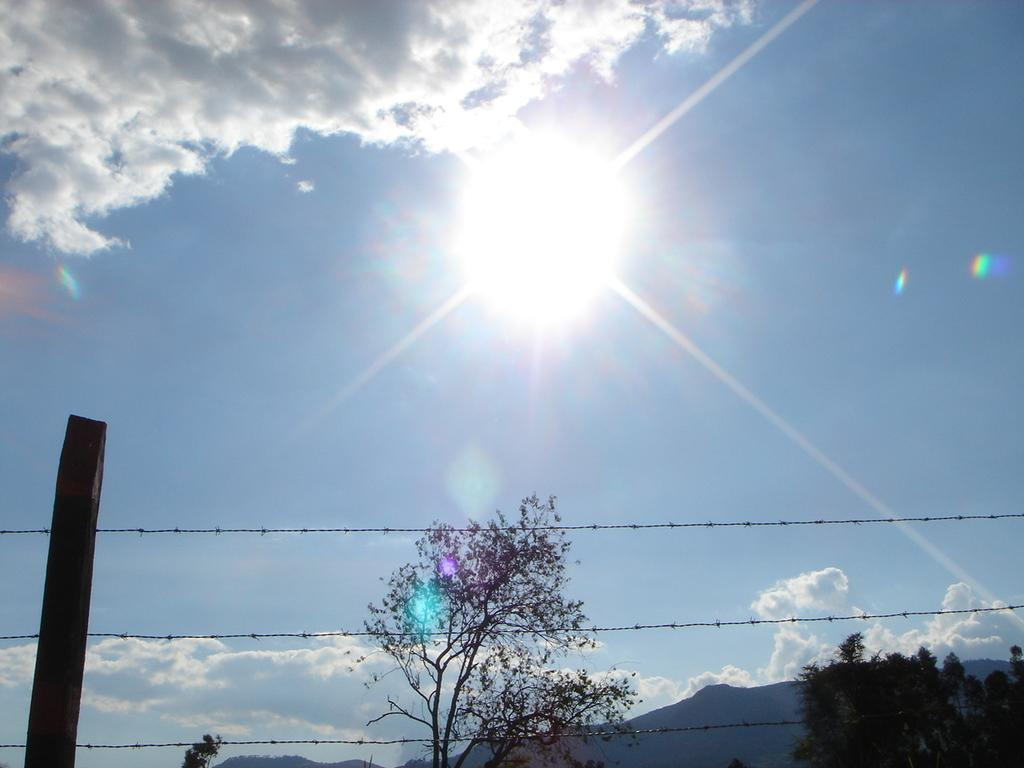What type of structure can be seen in the image? There are fencing wires in the image. What can be seen in the distance behind the fencing wires? There are trees in the background of the image. What is visible in the sky in the background of the image? There are clouds in the sky in the background of the image. What type of rock is being bitten by the person in the image? There is no person or rock present in the image; it only features fencing wires, trees, and clouds. 